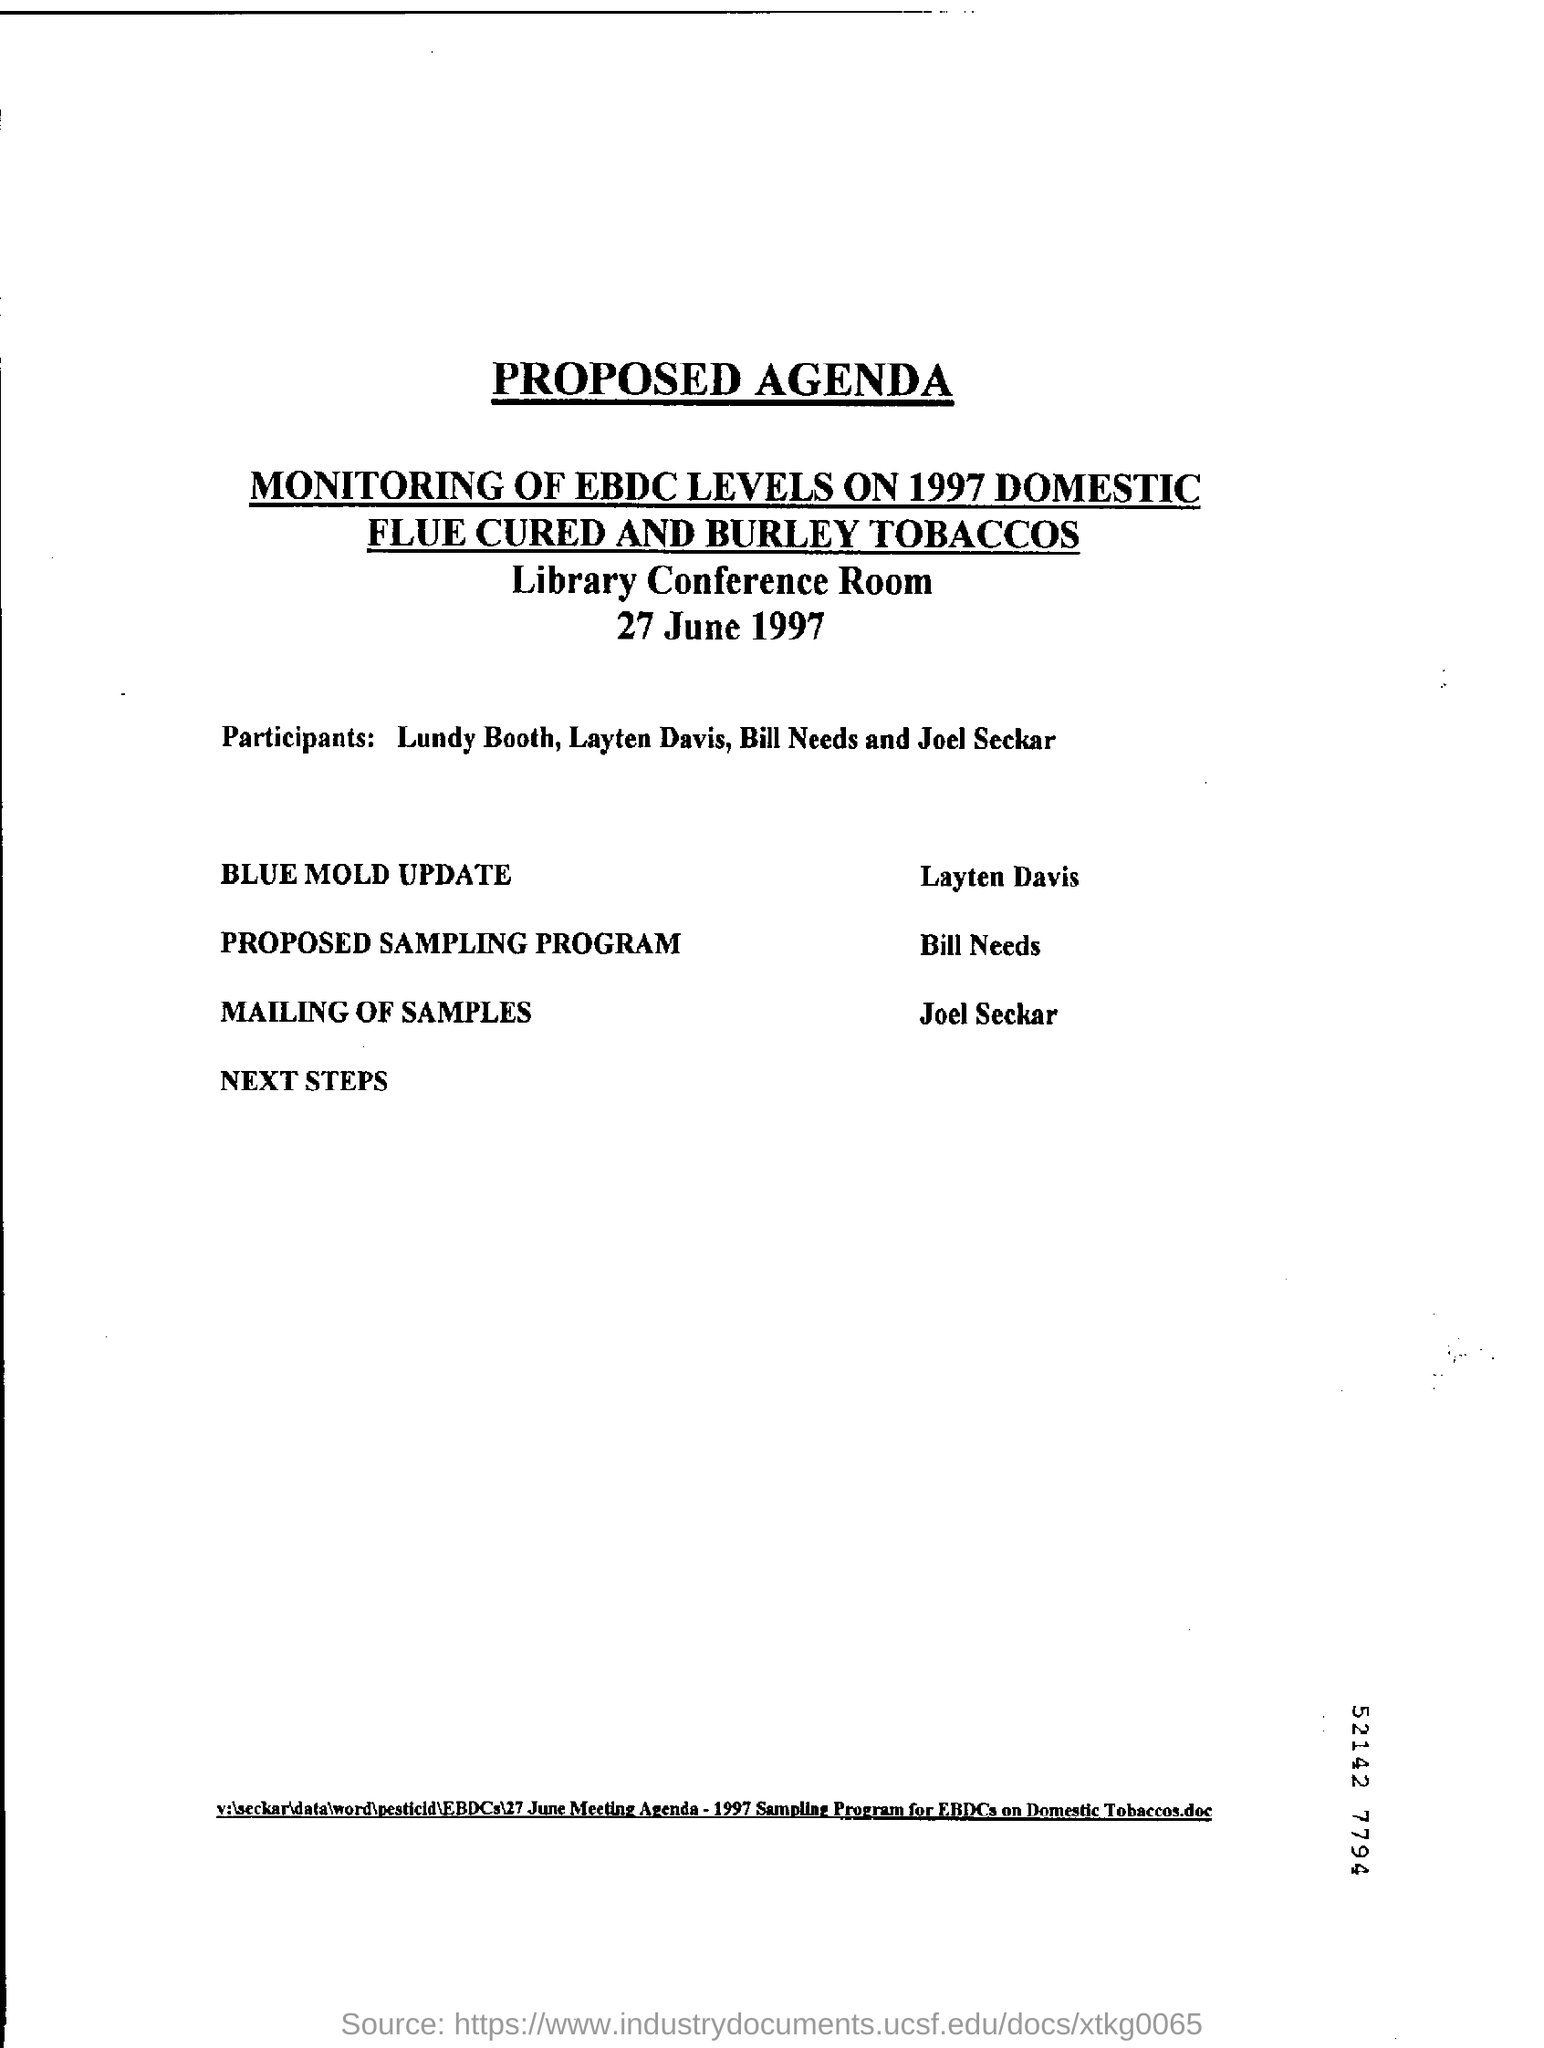Who will do the BLUE MOLD UPDATE?
Ensure brevity in your answer.  Layten Davis. When is the program going to be held?
Offer a very short reply. 27 June 1997. Which two tobacco types are mentioned?
Your response must be concise. FLUE CURED AND BURLEY. 